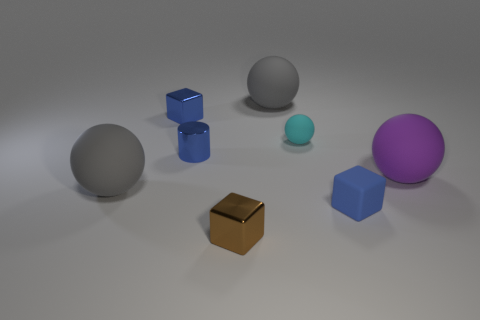What number of large gray things are on the right side of the shiny block behind the blue thing that is to the right of the brown shiny object?
Your answer should be very brief. 1. There is a big rubber thing that is to the left of the brown metal thing; is it the same color as the large rubber sphere on the right side of the small matte block?
Ensure brevity in your answer.  No. What color is the large object that is both to the right of the tiny brown thing and to the left of the purple ball?
Provide a succinct answer. Gray. How many cylinders have the same size as the blue matte block?
Offer a very short reply. 1. There is a large thing that is behind the blue object that is behind the cyan rubber object; what is its shape?
Your response must be concise. Sphere. The large gray matte object behind the big matte ball right of the cube that is right of the cyan rubber ball is what shape?
Offer a terse response. Sphere. What number of other small cyan objects are the same shape as the tiny cyan thing?
Make the answer very short. 0. There is a small block that is right of the brown metallic object; what number of big gray rubber spheres are in front of it?
Offer a terse response. 0. How many matte objects are either small blue things or small things?
Keep it short and to the point. 2. Is there a big cylinder made of the same material as the cyan sphere?
Make the answer very short. No. 